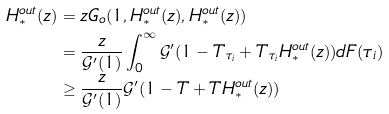Convert formula to latex. <formula><loc_0><loc_0><loc_500><loc_500>H _ { \ast } ^ { o u t } ( z ) & = z G _ { o } ( 1 , H _ { \ast } ^ { o u t } ( z ) , H _ { \ast } ^ { o u t } ( z ) ) \\ & = \frac { z } { \mathcal { G } ^ { \prime } ( 1 ) } \int _ { 0 } ^ { \infty } \mathcal { G } ^ { \prime } ( 1 - T _ { \tau _ { i } } + T _ { \tau _ { i } } H _ { \ast } ^ { o u t } ( z ) ) d F ( \tau _ { i } ) \\ & \geq \frac { z } { \mathcal { G } ^ { \prime } ( 1 ) } \mathcal { G } ^ { \prime } ( 1 - T + T H _ { \ast } ^ { o u t } ( z ) )</formula> 